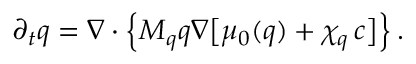Convert formula to latex. <formula><loc_0><loc_0><loc_500><loc_500>\partial _ { t } q = \boldsymbol \nabla \cdot \left \{ M _ { q } q \boldsymbol \nabla \left [ \mu _ { 0 } ( q ) + \chi _ { q } \, c \right ] \right \} \, .</formula> 